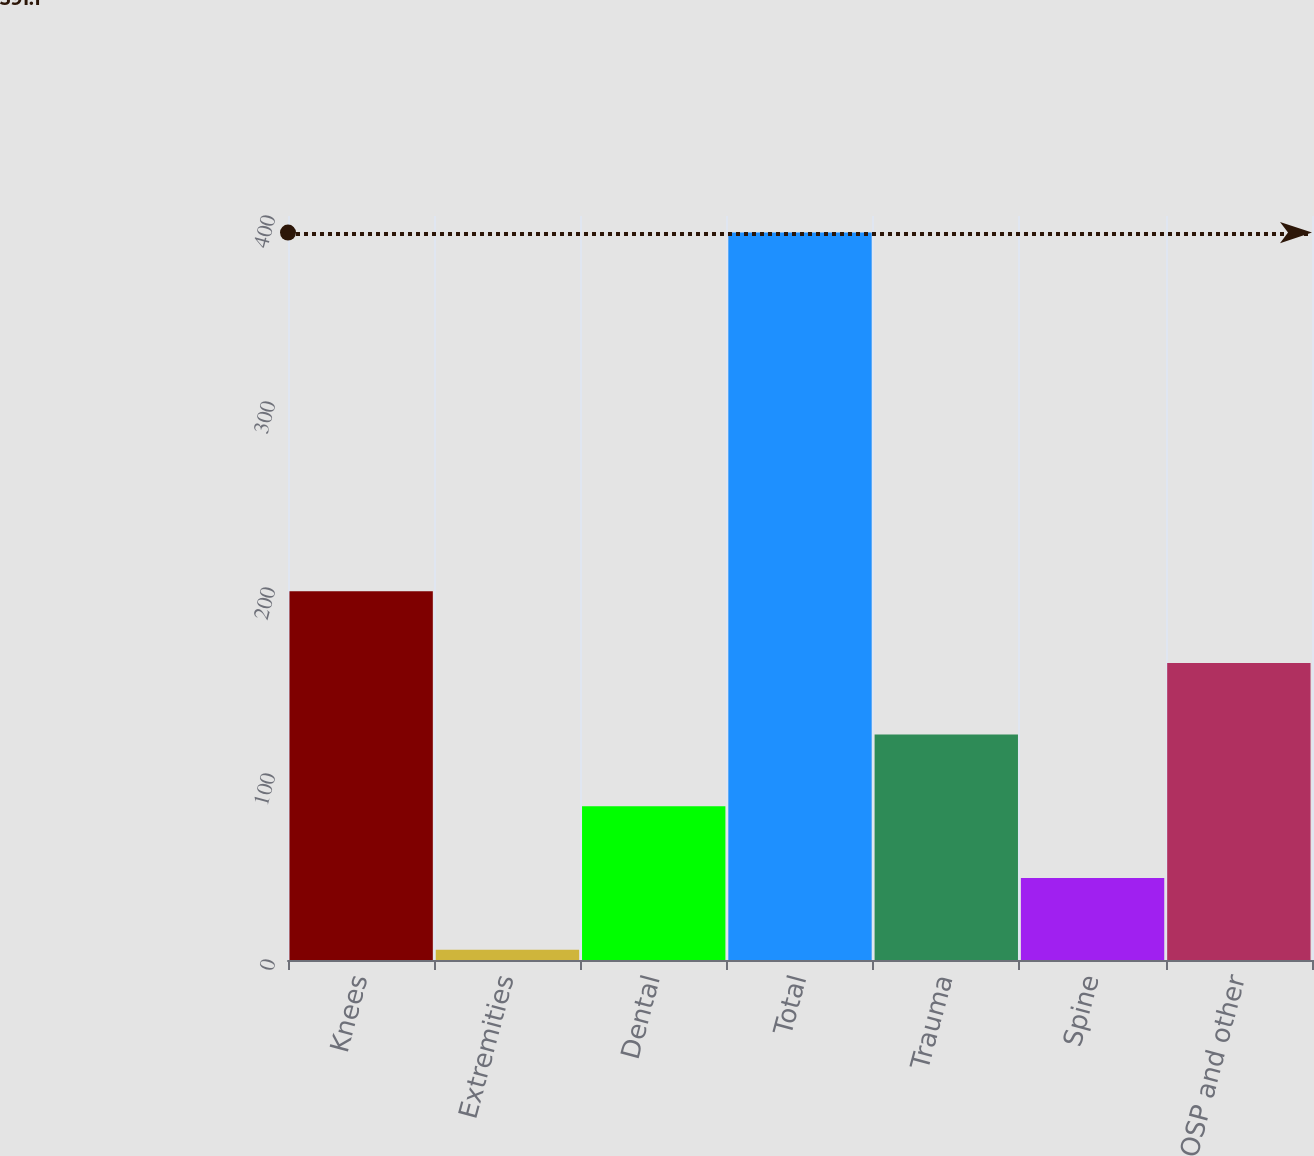Convert chart to OTSL. <chart><loc_0><loc_0><loc_500><loc_500><bar_chart><fcel>Knees<fcel>Extremities<fcel>Dental<fcel>Total<fcel>Trauma<fcel>Spine<fcel>OSP and other<nl><fcel>198.3<fcel>5.5<fcel>82.62<fcel>391.1<fcel>121.18<fcel>44.06<fcel>159.74<nl></chart> 